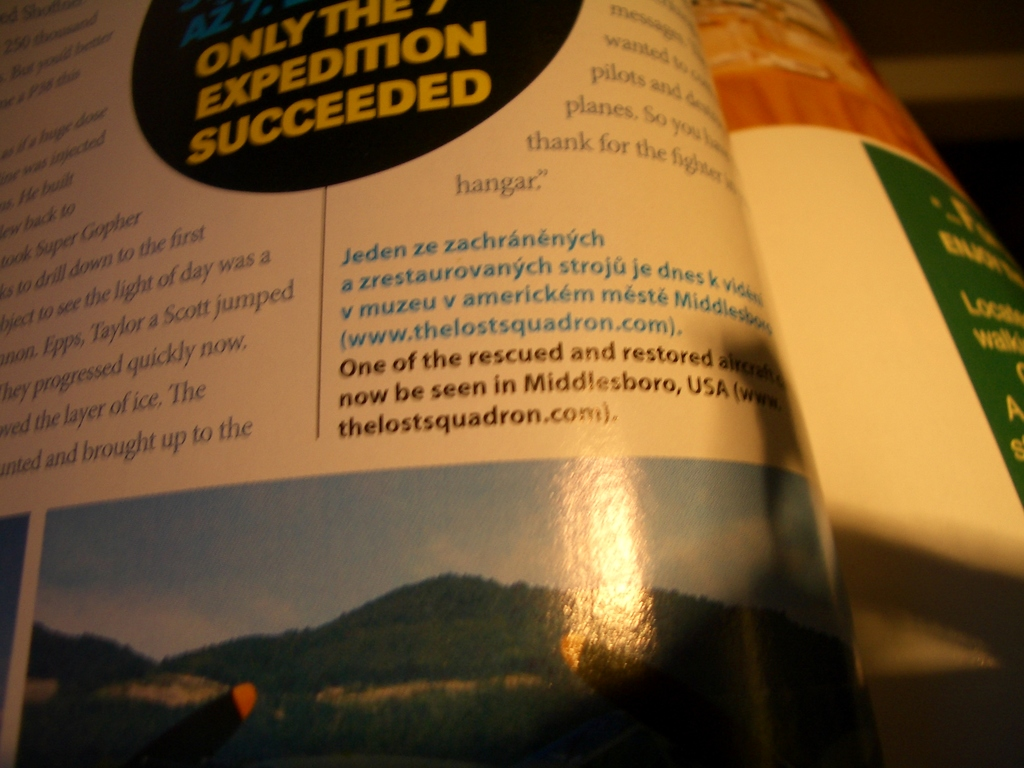What significant event does 'ONLY THE 7TH EXPEDITION SUCCEEDED' refer to, and why is it important? This phrase refers to the successful recovery of a historically significant aircraft, part of an expedition that uncovered lost airplanes from World War II. The successful seventh attempt has become a notable event because it salvaged a piece of aviation and military history, now preserved in a museum in Middlesboro, USA. 